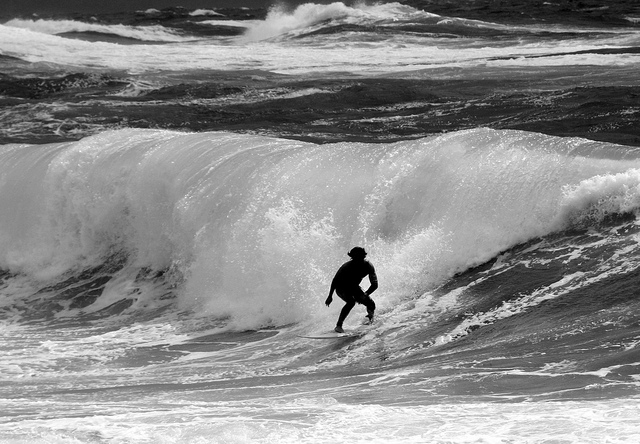Describe the surfer's stance and technique. The surfer exhibits a poised and balanced stance, with one foot forward and arms extended for stability, showcasing proficient technique to navigate the dynamic movement of the wave. 